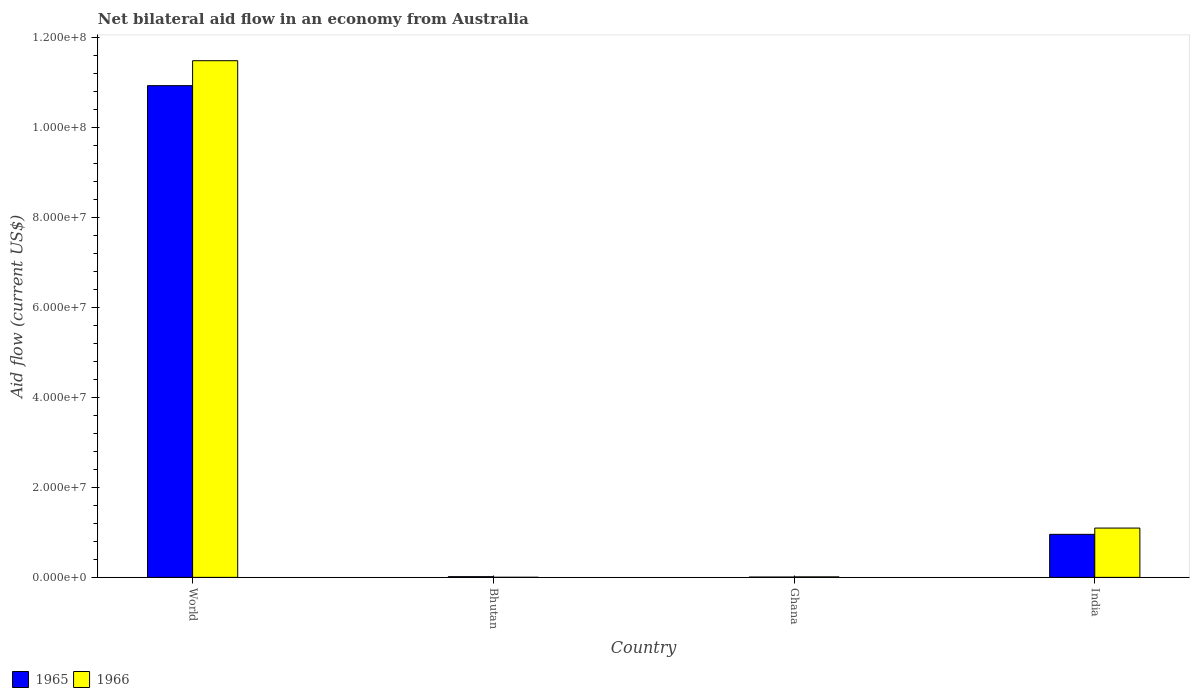How many different coloured bars are there?
Give a very brief answer. 2. How many groups of bars are there?
Give a very brief answer. 4. Are the number of bars on each tick of the X-axis equal?
Provide a succinct answer. Yes. How many bars are there on the 2nd tick from the right?
Your answer should be compact. 2. What is the net bilateral aid flow in 1966 in Ghana?
Give a very brief answer. 1.10e+05. Across all countries, what is the maximum net bilateral aid flow in 1965?
Your answer should be compact. 1.09e+08. In which country was the net bilateral aid flow in 1965 maximum?
Offer a terse response. World. In which country was the net bilateral aid flow in 1966 minimum?
Your answer should be very brief. Bhutan. What is the total net bilateral aid flow in 1965 in the graph?
Make the answer very short. 1.19e+08. What is the difference between the net bilateral aid flow in 1966 in Bhutan and that in Ghana?
Provide a short and direct response. -9.00e+04. What is the difference between the net bilateral aid flow in 1965 in India and the net bilateral aid flow in 1966 in World?
Offer a very short reply. -1.05e+08. What is the average net bilateral aid flow in 1965 per country?
Ensure brevity in your answer.  2.98e+07. What is the difference between the net bilateral aid flow of/in 1965 and net bilateral aid flow of/in 1966 in Bhutan?
Give a very brief answer. 1.30e+05. What is the ratio of the net bilateral aid flow in 1966 in Bhutan to that in Ghana?
Offer a terse response. 0.18. Is the net bilateral aid flow in 1966 in Ghana less than that in World?
Offer a terse response. Yes. What is the difference between the highest and the second highest net bilateral aid flow in 1966?
Give a very brief answer. 1.04e+08. What is the difference between the highest and the lowest net bilateral aid flow in 1965?
Offer a very short reply. 1.09e+08. What does the 2nd bar from the left in Bhutan represents?
Offer a terse response. 1966. What does the 2nd bar from the right in Ghana represents?
Offer a very short reply. 1965. How many bars are there?
Your answer should be compact. 8. How many countries are there in the graph?
Provide a short and direct response. 4. What is the difference between two consecutive major ticks on the Y-axis?
Give a very brief answer. 2.00e+07. Are the values on the major ticks of Y-axis written in scientific E-notation?
Keep it short and to the point. Yes. How many legend labels are there?
Make the answer very short. 2. What is the title of the graph?
Provide a succinct answer. Net bilateral aid flow in an economy from Australia. Does "1996" appear as one of the legend labels in the graph?
Your response must be concise. No. What is the label or title of the X-axis?
Offer a terse response. Country. What is the Aid flow (current US$) of 1965 in World?
Give a very brief answer. 1.09e+08. What is the Aid flow (current US$) in 1966 in World?
Provide a short and direct response. 1.15e+08. What is the Aid flow (current US$) in 1966 in Bhutan?
Ensure brevity in your answer.  2.00e+04. What is the Aid flow (current US$) of 1965 in Ghana?
Give a very brief answer. 7.00e+04. What is the Aid flow (current US$) in 1966 in Ghana?
Offer a very short reply. 1.10e+05. What is the Aid flow (current US$) of 1965 in India?
Your answer should be very brief. 9.56e+06. What is the Aid flow (current US$) in 1966 in India?
Your response must be concise. 1.10e+07. Across all countries, what is the maximum Aid flow (current US$) in 1965?
Offer a very short reply. 1.09e+08. Across all countries, what is the maximum Aid flow (current US$) in 1966?
Your response must be concise. 1.15e+08. What is the total Aid flow (current US$) in 1965 in the graph?
Make the answer very short. 1.19e+08. What is the total Aid flow (current US$) of 1966 in the graph?
Offer a terse response. 1.26e+08. What is the difference between the Aid flow (current US$) of 1965 in World and that in Bhutan?
Your response must be concise. 1.09e+08. What is the difference between the Aid flow (current US$) in 1966 in World and that in Bhutan?
Offer a very short reply. 1.15e+08. What is the difference between the Aid flow (current US$) of 1965 in World and that in Ghana?
Provide a succinct answer. 1.09e+08. What is the difference between the Aid flow (current US$) of 1966 in World and that in Ghana?
Your answer should be very brief. 1.15e+08. What is the difference between the Aid flow (current US$) in 1965 in World and that in India?
Give a very brief answer. 9.97e+07. What is the difference between the Aid flow (current US$) in 1966 in World and that in India?
Offer a terse response. 1.04e+08. What is the difference between the Aid flow (current US$) in 1965 in Bhutan and that in Ghana?
Ensure brevity in your answer.  8.00e+04. What is the difference between the Aid flow (current US$) of 1965 in Bhutan and that in India?
Make the answer very short. -9.41e+06. What is the difference between the Aid flow (current US$) in 1966 in Bhutan and that in India?
Your response must be concise. -1.09e+07. What is the difference between the Aid flow (current US$) in 1965 in Ghana and that in India?
Offer a very short reply. -9.49e+06. What is the difference between the Aid flow (current US$) of 1966 in Ghana and that in India?
Your response must be concise. -1.08e+07. What is the difference between the Aid flow (current US$) of 1965 in World and the Aid flow (current US$) of 1966 in Bhutan?
Provide a short and direct response. 1.09e+08. What is the difference between the Aid flow (current US$) of 1965 in World and the Aid flow (current US$) of 1966 in Ghana?
Ensure brevity in your answer.  1.09e+08. What is the difference between the Aid flow (current US$) in 1965 in World and the Aid flow (current US$) in 1966 in India?
Keep it short and to the point. 9.83e+07. What is the difference between the Aid flow (current US$) of 1965 in Bhutan and the Aid flow (current US$) of 1966 in India?
Make the answer very short. -1.08e+07. What is the difference between the Aid flow (current US$) of 1965 in Ghana and the Aid flow (current US$) of 1966 in India?
Provide a succinct answer. -1.09e+07. What is the average Aid flow (current US$) in 1965 per country?
Offer a terse response. 2.98e+07. What is the average Aid flow (current US$) in 1966 per country?
Keep it short and to the point. 3.15e+07. What is the difference between the Aid flow (current US$) of 1965 and Aid flow (current US$) of 1966 in World?
Your answer should be compact. -5.54e+06. What is the difference between the Aid flow (current US$) in 1965 and Aid flow (current US$) in 1966 in India?
Keep it short and to the point. -1.39e+06. What is the ratio of the Aid flow (current US$) of 1965 in World to that in Bhutan?
Keep it short and to the point. 728.33. What is the ratio of the Aid flow (current US$) in 1966 in World to that in Bhutan?
Your answer should be compact. 5739.5. What is the ratio of the Aid flow (current US$) of 1965 in World to that in Ghana?
Provide a short and direct response. 1560.71. What is the ratio of the Aid flow (current US$) of 1966 in World to that in Ghana?
Offer a very short reply. 1043.55. What is the ratio of the Aid flow (current US$) in 1965 in World to that in India?
Your answer should be very brief. 11.43. What is the ratio of the Aid flow (current US$) of 1966 in World to that in India?
Offer a very short reply. 10.48. What is the ratio of the Aid flow (current US$) in 1965 in Bhutan to that in Ghana?
Provide a short and direct response. 2.14. What is the ratio of the Aid flow (current US$) in 1966 in Bhutan to that in Ghana?
Make the answer very short. 0.18. What is the ratio of the Aid flow (current US$) of 1965 in Bhutan to that in India?
Your answer should be very brief. 0.02. What is the ratio of the Aid flow (current US$) in 1966 in Bhutan to that in India?
Your answer should be very brief. 0. What is the ratio of the Aid flow (current US$) in 1965 in Ghana to that in India?
Ensure brevity in your answer.  0.01. What is the difference between the highest and the second highest Aid flow (current US$) in 1965?
Provide a short and direct response. 9.97e+07. What is the difference between the highest and the second highest Aid flow (current US$) in 1966?
Offer a terse response. 1.04e+08. What is the difference between the highest and the lowest Aid flow (current US$) of 1965?
Offer a terse response. 1.09e+08. What is the difference between the highest and the lowest Aid flow (current US$) in 1966?
Your answer should be very brief. 1.15e+08. 